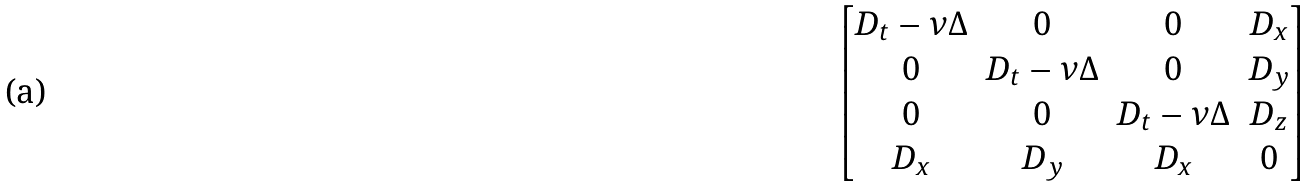Convert formula to latex. <formula><loc_0><loc_0><loc_500><loc_500>\begin{bmatrix} D _ { t } - \nu \Delta & 0 & 0 & D _ { x } \\ 0 & D _ { t } - \nu \Delta & 0 & D _ { y } \\ 0 & 0 & D _ { t } - \nu \Delta & D _ { z } \\ D _ { x } & D _ { y } & D _ { x } & 0 \end{bmatrix}</formula> 